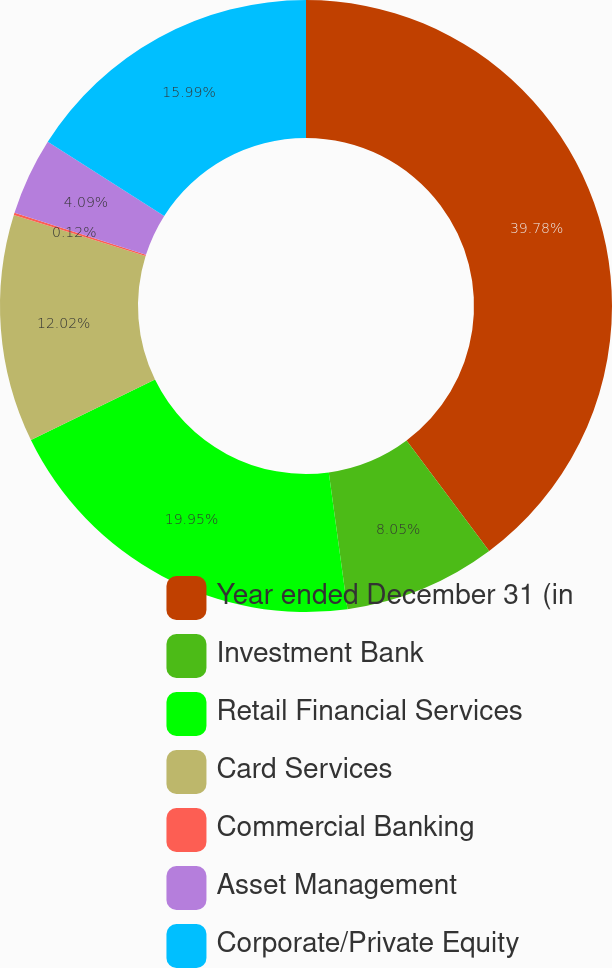Convert chart. <chart><loc_0><loc_0><loc_500><loc_500><pie_chart><fcel>Year ended December 31 (in<fcel>Investment Bank<fcel>Retail Financial Services<fcel>Card Services<fcel>Commercial Banking<fcel>Asset Management<fcel>Corporate/Private Equity<nl><fcel>39.79%<fcel>8.05%<fcel>19.95%<fcel>12.02%<fcel>0.12%<fcel>4.09%<fcel>15.99%<nl></chart> 